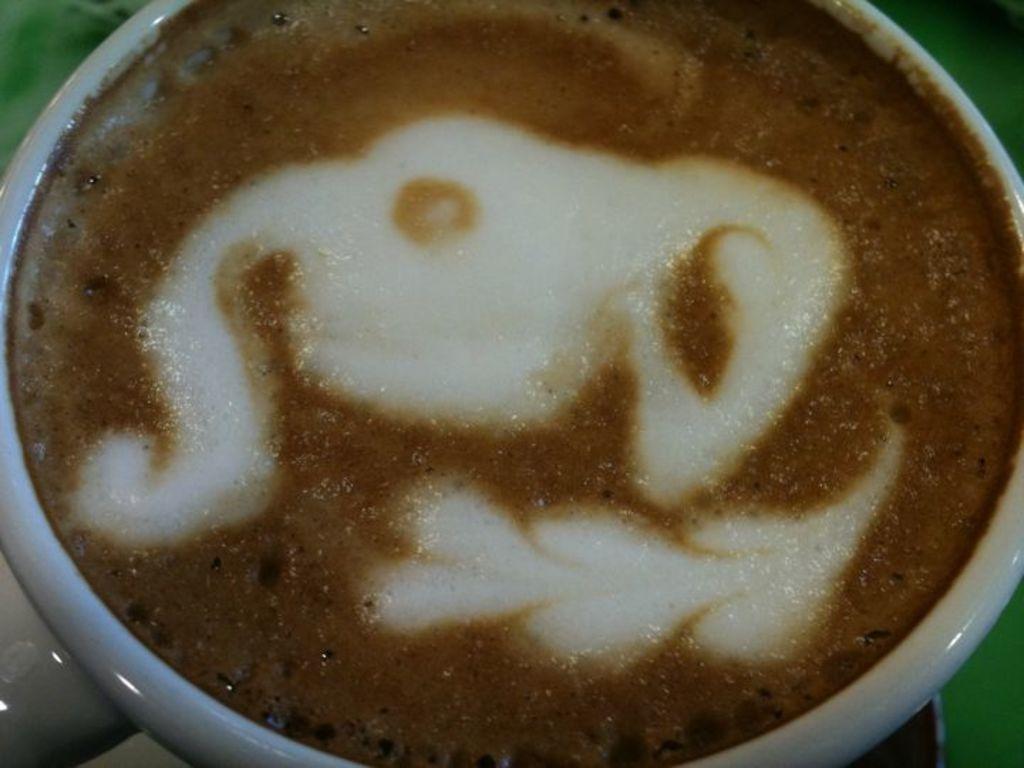Describe this image in one or two sentences. In this image there is a cup with coffee inside it. 